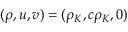<formula> <loc_0><loc_0><loc_500><loc_500>( \rho , u , v ) = ( \rho _ { K } , c \rho _ { K } , 0 )</formula> 